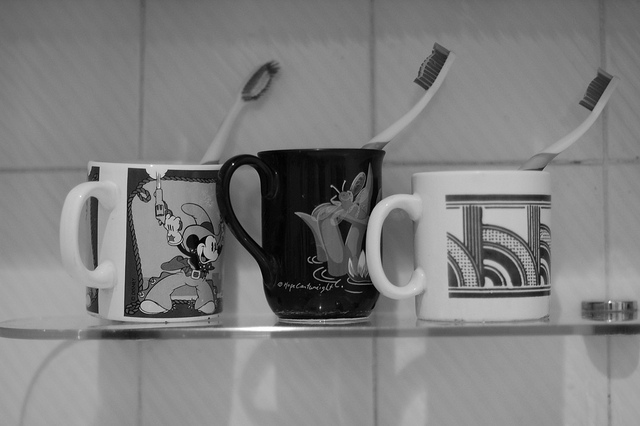<image>What animal shape is this? I don't know what animal shape this is. It can be a mouse or a unicorn, or there may be no animal shape. What is the consistent motif? I am not sure what the consistent motif is. It could be coffee mugs, toothbrush in a mug, or toothbrushes. What animal shape is this? I don't know what animal shape it is. It can be seen as a mouse or a unicorn. What is the consistent motif? I don't know what the consistent motif is. It could be coffee mugs, toothbrush in mug, mugs, brushes point right, period style, toothbrushes, toothbrush on right, or three. 